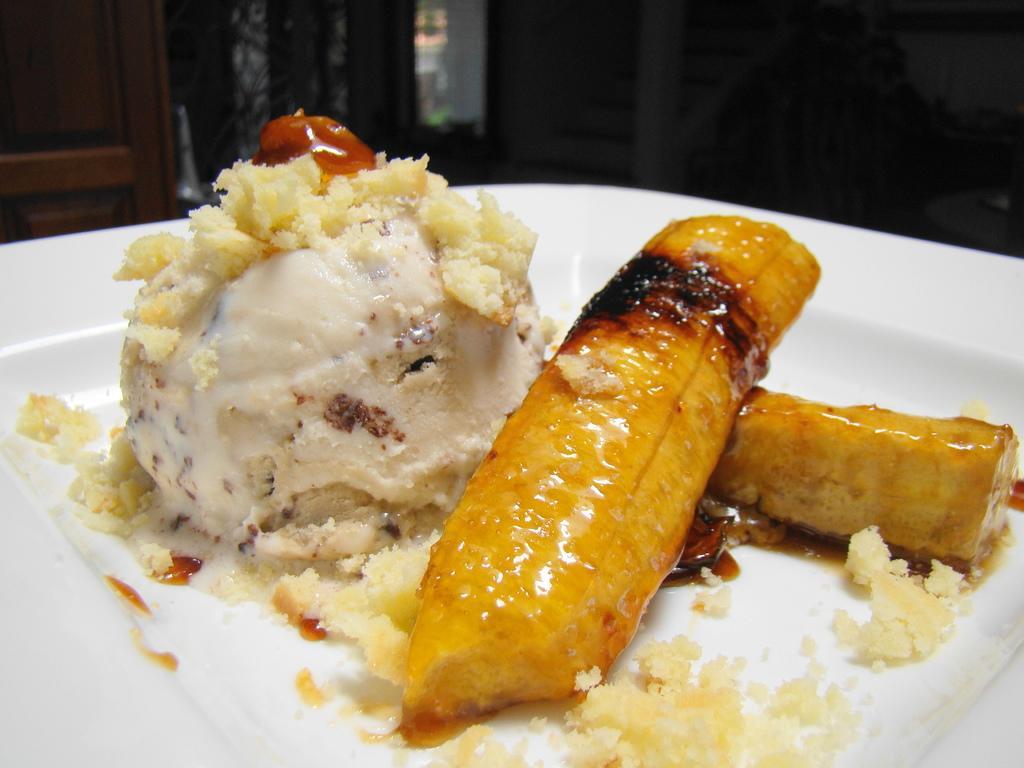Describe this image in one or two sentences. In this image, we can see some food items on a plate. We can also see the background with some objects. We can also see some wood. 